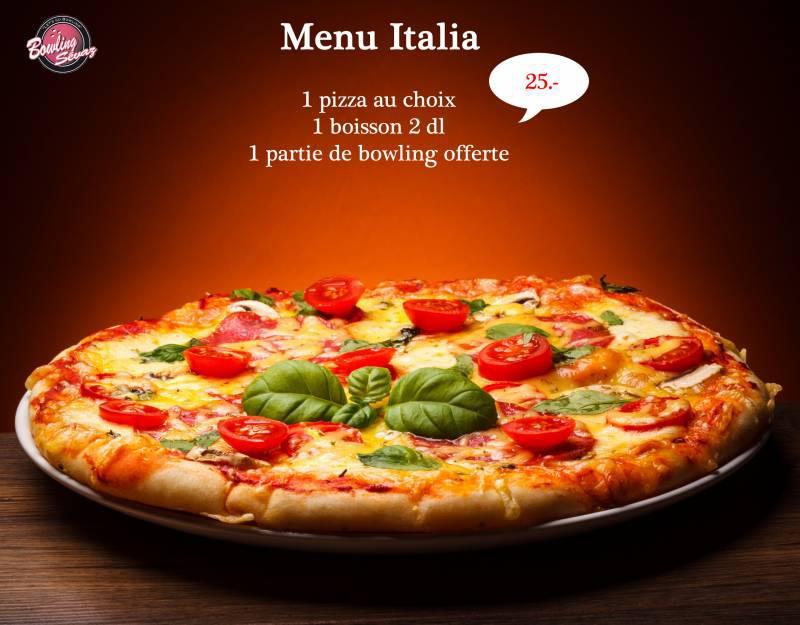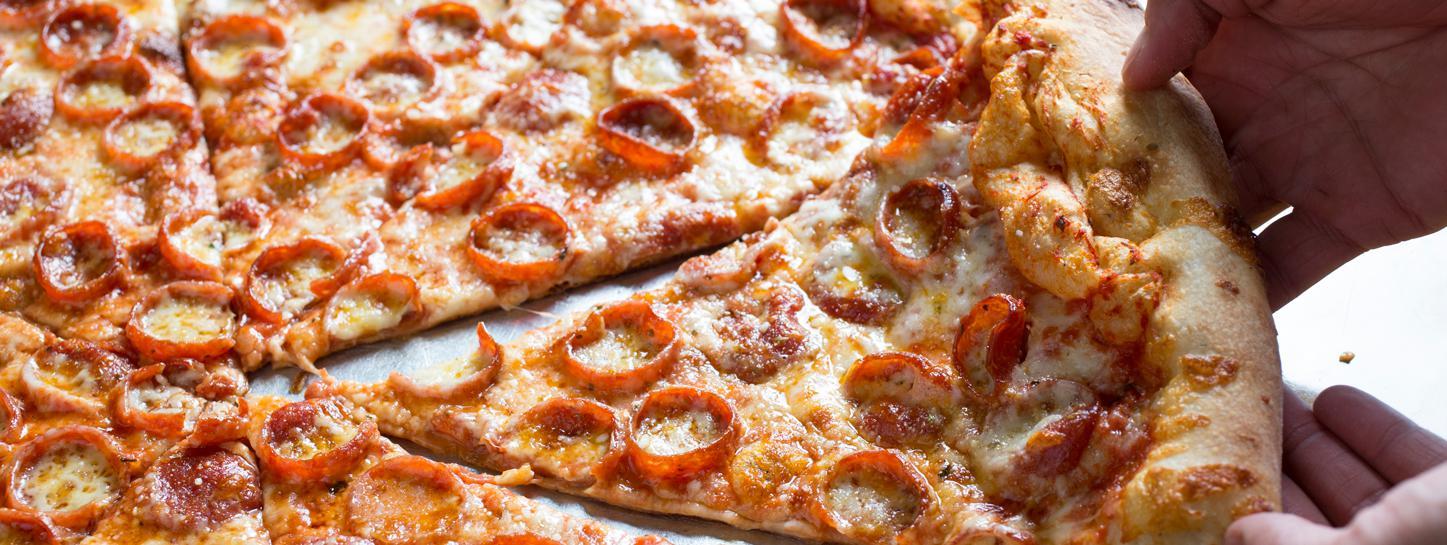The first image is the image on the left, the second image is the image on the right. Considering the images on both sides, is "The right image features one round pizza cut into at least six wedge-shaped slices and garnished with black caviar." valid? Answer yes or no. No. The first image is the image on the left, the second image is the image on the right. For the images shown, is this caption "In at least one image there is a salmon and carvery pizza with at least six slices." true? Answer yes or no. No. 